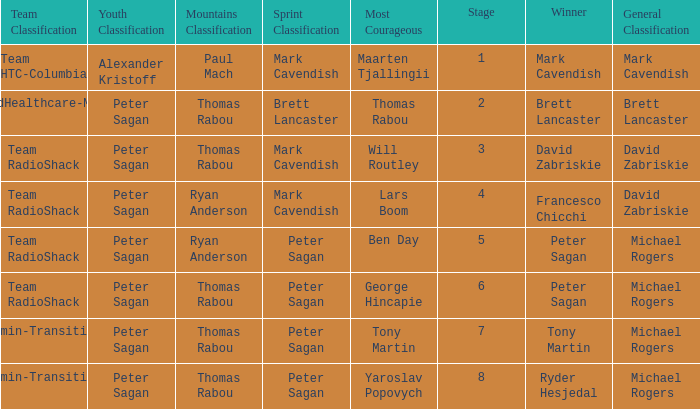Who won the mountains classification when Maarten Tjallingii won most corageous? Paul Mach. 